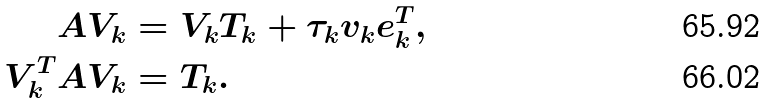Convert formula to latex. <formula><loc_0><loc_0><loc_500><loc_500>A V _ { k } & = V _ { k } T _ { k } + \tau _ { k } v _ { k } e _ { k } ^ { T } , \\ V _ { k } ^ { T } A V _ { k } & = T _ { k } .</formula> 